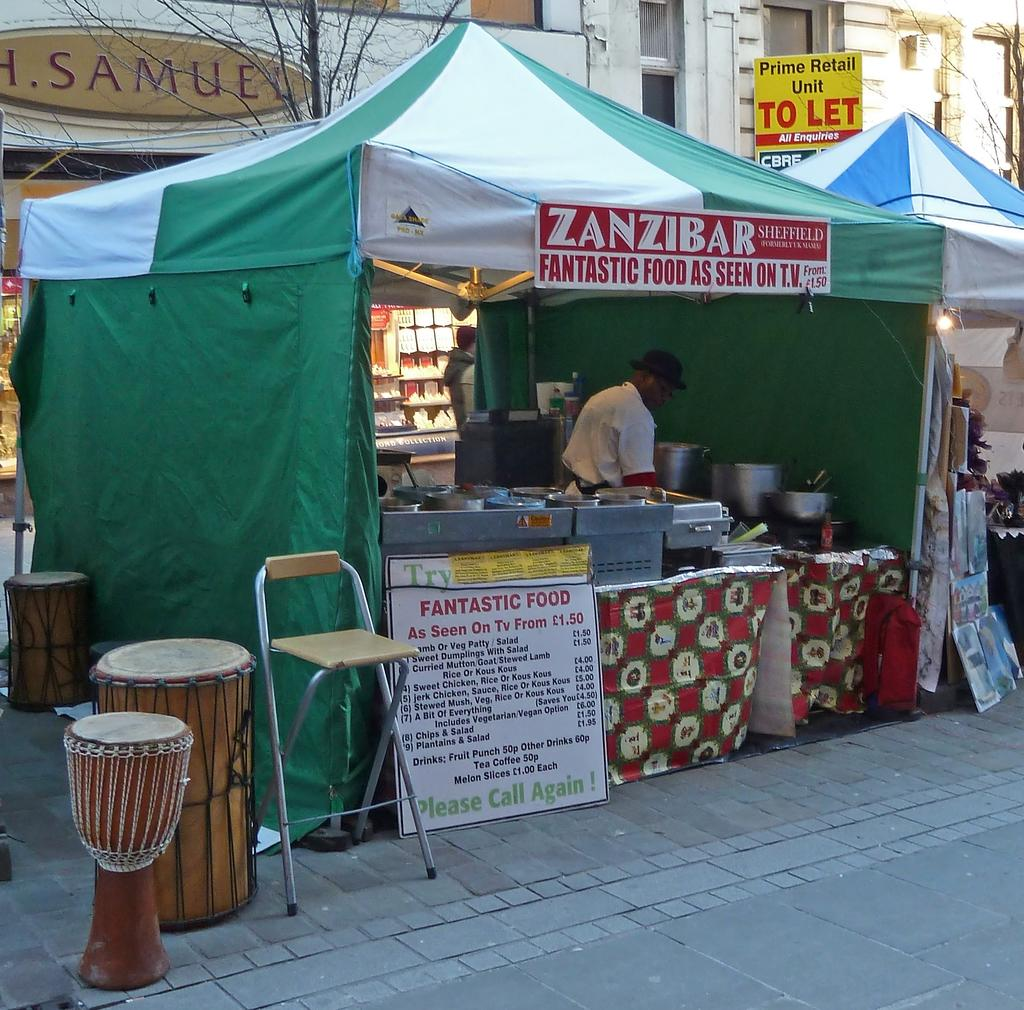Where is the person located in the image? The person is inside a food court. What musical instrument can be seen in the image? There are drums in the image. What type of furniture is present in the image? There are chairs in the image. What type of signage is present in the image? There is a banner in the image. What type of display is present in the image? There are boards in the image. What type of dishware is present in the image? There are bowls in the image. What type of outdoor feature is present in the image? There is a road in the image. What type of structure is visible in the background of the image? There is a building in the background of the image. How does the person's knee affect their hearing in the image? There is no information about the person's knee or hearing in the image, so we cannot determine any relationship between the two. 